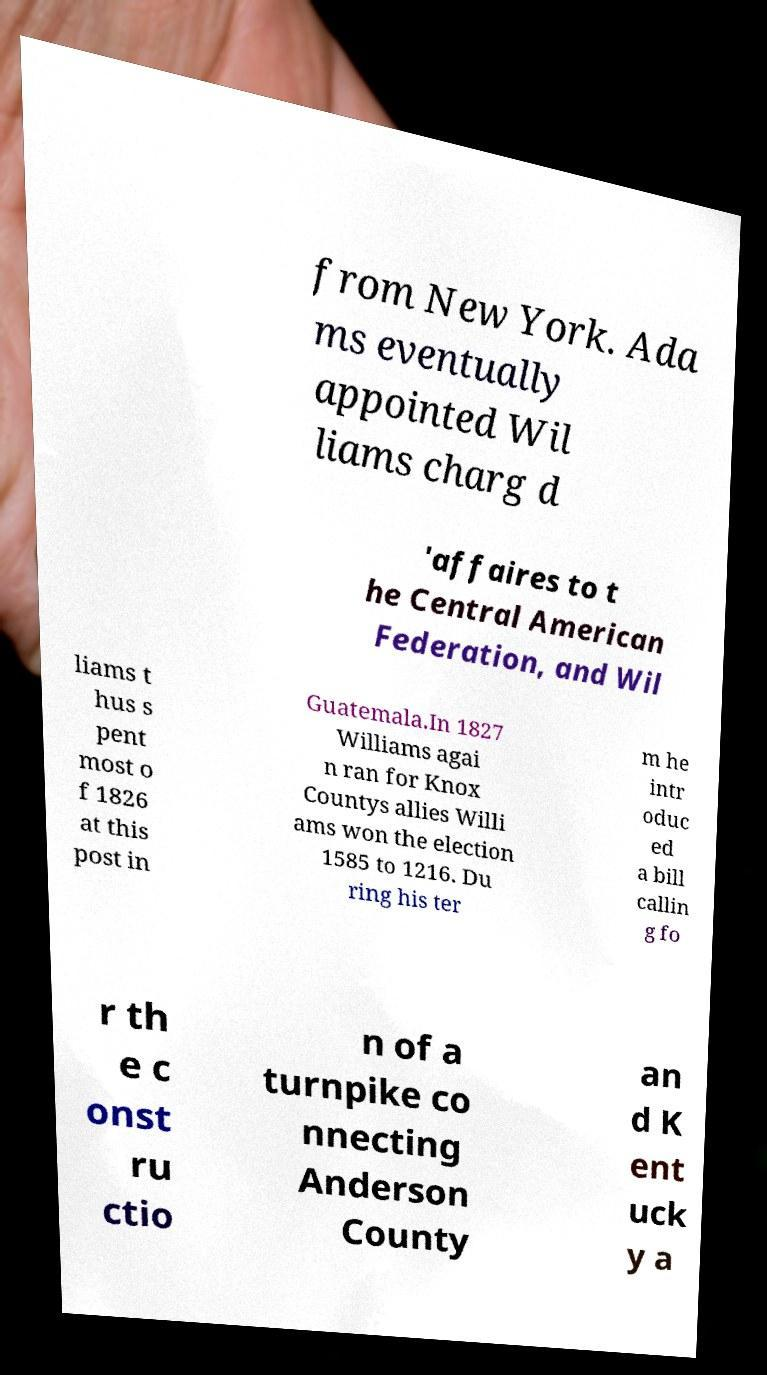Please read and relay the text visible in this image. What does it say? from New York. Ada ms eventually appointed Wil liams charg d 'affaires to t he Central American Federation, and Wil liams t hus s pent most o f 1826 at this post in Guatemala.In 1827 Williams agai n ran for Knox Countys allies Willi ams won the election 1585 to 1216. Du ring his ter m he intr oduc ed a bill callin g fo r th e c onst ru ctio n of a turnpike co nnecting Anderson County an d K ent uck y a 